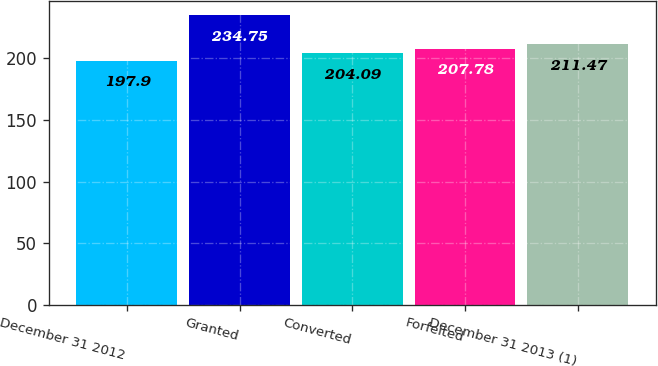Convert chart. <chart><loc_0><loc_0><loc_500><loc_500><bar_chart><fcel>December 31 2012<fcel>Granted<fcel>Converted<fcel>Forfeited<fcel>December 31 2013 (1)<nl><fcel>197.9<fcel>234.75<fcel>204.09<fcel>207.78<fcel>211.47<nl></chart> 